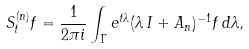<formula> <loc_0><loc_0><loc_500><loc_500>S ^ { ( n ) } _ { t } f = \frac { 1 } { 2 \pi i } \int _ { \Gamma } e ^ { t \lambda } ( \lambda \, I + A _ { n } ) ^ { - 1 } f \, d \lambda ,</formula> 